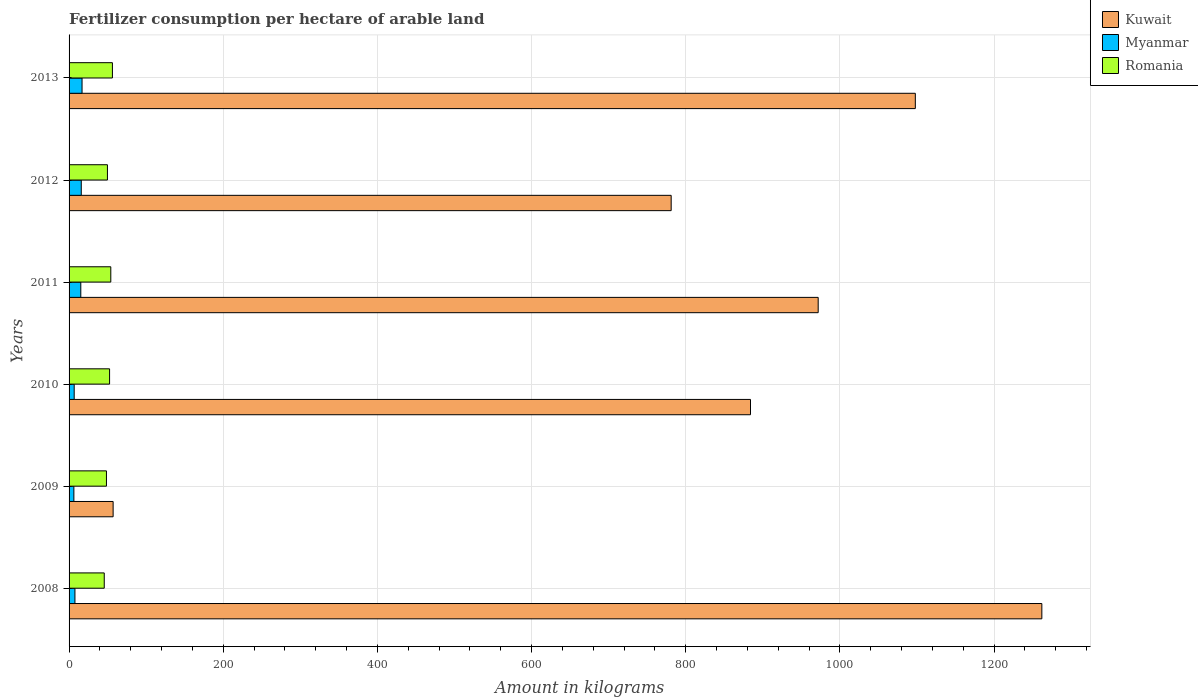How many different coloured bars are there?
Provide a succinct answer. 3. How many bars are there on the 1st tick from the top?
Provide a succinct answer. 3. What is the amount of fertilizer consumption in Kuwait in 2009?
Keep it short and to the point. 57.14. Across all years, what is the maximum amount of fertilizer consumption in Romania?
Make the answer very short. 56.23. Across all years, what is the minimum amount of fertilizer consumption in Romania?
Offer a very short reply. 45.64. In which year was the amount of fertilizer consumption in Myanmar maximum?
Offer a terse response. 2013. What is the total amount of fertilizer consumption in Romania in the graph?
Make the answer very short. 306.83. What is the difference between the amount of fertilizer consumption in Myanmar in 2009 and that in 2012?
Provide a short and direct response. -9.58. What is the difference between the amount of fertilizer consumption in Kuwait in 2011 and the amount of fertilizer consumption in Romania in 2013?
Your answer should be compact. 915.57. What is the average amount of fertilizer consumption in Myanmar per year?
Your response must be concise. 11.39. In the year 2008, what is the difference between the amount of fertilizer consumption in Romania and amount of fertilizer consumption in Kuwait?
Provide a short and direct response. -1216.31. In how many years, is the amount of fertilizer consumption in Romania greater than 360 kg?
Offer a very short reply. 0. What is the ratio of the amount of fertilizer consumption in Romania in 2008 to that in 2009?
Provide a succinct answer. 0.94. Is the amount of fertilizer consumption in Myanmar in 2008 less than that in 2011?
Provide a short and direct response. Yes. What is the difference between the highest and the second highest amount of fertilizer consumption in Myanmar?
Offer a very short reply. 1.02. What is the difference between the highest and the lowest amount of fertilizer consumption in Romania?
Provide a succinct answer. 10.6. In how many years, is the amount of fertilizer consumption in Myanmar greater than the average amount of fertilizer consumption in Myanmar taken over all years?
Provide a short and direct response. 3. What does the 1st bar from the top in 2008 represents?
Your response must be concise. Romania. What does the 2nd bar from the bottom in 2009 represents?
Give a very brief answer. Myanmar. How many bars are there?
Provide a succinct answer. 18. How many years are there in the graph?
Your answer should be compact. 6. What is the difference between two consecutive major ticks on the X-axis?
Ensure brevity in your answer.  200. How many legend labels are there?
Provide a short and direct response. 3. How are the legend labels stacked?
Your answer should be compact. Vertical. What is the title of the graph?
Give a very brief answer. Fertilizer consumption per hectare of arable land. Does "Mongolia" appear as one of the legend labels in the graph?
Offer a terse response. No. What is the label or title of the X-axis?
Offer a very short reply. Amount in kilograms. What is the Amount in kilograms of Kuwait in 2008?
Your answer should be compact. 1261.95. What is the Amount in kilograms of Myanmar in 2008?
Give a very brief answer. 7.61. What is the Amount in kilograms of Romania in 2008?
Make the answer very short. 45.64. What is the Amount in kilograms in Kuwait in 2009?
Ensure brevity in your answer.  57.14. What is the Amount in kilograms in Myanmar in 2009?
Keep it short and to the point. 6.24. What is the Amount in kilograms of Romania in 2009?
Your response must be concise. 48.49. What is the Amount in kilograms of Kuwait in 2010?
Your answer should be compact. 884. What is the Amount in kilograms of Myanmar in 2010?
Offer a terse response. 6.64. What is the Amount in kilograms of Romania in 2010?
Provide a short and direct response. 52.55. What is the Amount in kilograms in Kuwait in 2011?
Keep it short and to the point. 971.81. What is the Amount in kilograms of Myanmar in 2011?
Make the answer very short. 15.22. What is the Amount in kilograms in Romania in 2011?
Offer a very short reply. 54.13. What is the Amount in kilograms in Kuwait in 2012?
Make the answer very short. 781.1. What is the Amount in kilograms in Myanmar in 2012?
Your answer should be compact. 15.82. What is the Amount in kilograms of Romania in 2012?
Your response must be concise. 49.78. What is the Amount in kilograms in Kuwait in 2013?
Your answer should be compact. 1097.83. What is the Amount in kilograms in Myanmar in 2013?
Offer a very short reply. 16.83. What is the Amount in kilograms of Romania in 2013?
Provide a succinct answer. 56.23. Across all years, what is the maximum Amount in kilograms in Kuwait?
Provide a short and direct response. 1261.95. Across all years, what is the maximum Amount in kilograms in Myanmar?
Provide a succinct answer. 16.83. Across all years, what is the maximum Amount in kilograms in Romania?
Offer a terse response. 56.23. Across all years, what is the minimum Amount in kilograms in Kuwait?
Your answer should be compact. 57.14. Across all years, what is the minimum Amount in kilograms of Myanmar?
Your answer should be compact. 6.24. Across all years, what is the minimum Amount in kilograms of Romania?
Ensure brevity in your answer.  45.64. What is the total Amount in kilograms in Kuwait in the graph?
Provide a short and direct response. 5053.83. What is the total Amount in kilograms of Myanmar in the graph?
Offer a very short reply. 68.35. What is the total Amount in kilograms in Romania in the graph?
Provide a short and direct response. 306.83. What is the difference between the Amount in kilograms of Kuwait in 2008 and that in 2009?
Your answer should be compact. 1204.8. What is the difference between the Amount in kilograms in Myanmar in 2008 and that in 2009?
Give a very brief answer. 1.37. What is the difference between the Amount in kilograms of Romania in 2008 and that in 2009?
Your response must be concise. -2.86. What is the difference between the Amount in kilograms in Kuwait in 2008 and that in 2010?
Provide a short and direct response. 377.95. What is the difference between the Amount in kilograms in Myanmar in 2008 and that in 2010?
Offer a terse response. 0.97. What is the difference between the Amount in kilograms of Romania in 2008 and that in 2010?
Your answer should be very brief. -6.91. What is the difference between the Amount in kilograms of Kuwait in 2008 and that in 2011?
Provide a short and direct response. 290.14. What is the difference between the Amount in kilograms in Myanmar in 2008 and that in 2011?
Ensure brevity in your answer.  -7.61. What is the difference between the Amount in kilograms in Romania in 2008 and that in 2011?
Offer a terse response. -8.5. What is the difference between the Amount in kilograms of Kuwait in 2008 and that in 2012?
Provide a short and direct response. 480.85. What is the difference between the Amount in kilograms of Myanmar in 2008 and that in 2012?
Provide a short and direct response. -8.21. What is the difference between the Amount in kilograms of Romania in 2008 and that in 2012?
Offer a very short reply. -4.15. What is the difference between the Amount in kilograms in Kuwait in 2008 and that in 2013?
Offer a terse response. 164.12. What is the difference between the Amount in kilograms of Myanmar in 2008 and that in 2013?
Provide a succinct answer. -9.22. What is the difference between the Amount in kilograms in Romania in 2008 and that in 2013?
Provide a succinct answer. -10.6. What is the difference between the Amount in kilograms of Kuwait in 2009 and that in 2010?
Your response must be concise. -826.86. What is the difference between the Amount in kilograms of Myanmar in 2009 and that in 2010?
Give a very brief answer. -0.4. What is the difference between the Amount in kilograms of Romania in 2009 and that in 2010?
Give a very brief answer. -4.05. What is the difference between the Amount in kilograms of Kuwait in 2009 and that in 2011?
Keep it short and to the point. -914.67. What is the difference between the Amount in kilograms of Myanmar in 2009 and that in 2011?
Your answer should be very brief. -8.98. What is the difference between the Amount in kilograms in Romania in 2009 and that in 2011?
Make the answer very short. -5.64. What is the difference between the Amount in kilograms in Kuwait in 2009 and that in 2012?
Your answer should be compact. -723.96. What is the difference between the Amount in kilograms in Myanmar in 2009 and that in 2012?
Offer a very short reply. -9.58. What is the difference between the Amount in kilograms in Romania in 2009 and that in 2012?
Offer a terse response. -1.29. What is the difference between the Amount in kilograms of Kuwait in 2009 and that in 2013?
Keep it short and to the point. -1040.69. What is the difference between the Amount in kilograms of Myanmar in 2009 and that in 2013?
Offer a terse response. -10.6. What is the difference between the Amount in kilograms in Romania in 2009 and that in 2013?
Your answer should be compact. -7.74. What is the difference between the Amount in kilograms in Kuwait in 2010 and that in 2011?
Make the answer very short. -87.81. What is the difference between the Amount in kilograms of Myanmar in 2010 and that in 2011?
Ensure brevity in your answer.  -8.58. What is the difference between the Amount in kilograms in Romania in 2010 and that in 2011?
Ensure brevity in your answer.  -1.59. What is the difference between the Amount in kilograms of Kuwait in 2010 and that in 2012?
Your answer should be very brief. 102.9. What is the difference between the Amount in kilograms of Myanmar in 2010 and that in 2012?
Offer a very short reply. -9.18. What is the difference between the Amount in kilograms of Romania in 2010 and that in 2012?
Give a very brief answer. 2.77. What is the difference between the Amount in kilograms of Kuwait in 2010 and that in 2013?
Your response must be concise. -213.83. What is the difference between the Amount in kilograms in Myanmar in 2010 and that in 2013?
Ensure brevity in your answer.  -10.2. What is the difference between the Amount in kilograms in Romania in 2010 and that in 2013?
Your answer should be very brief. -3.69. What is the difference between the Amount in kilograms of Kuwait in 2011 and that in 2012?
Give a very brief answer. 190.71. What is the difference between the Amount in kilograms in Myanmar in 2011 and that in 2012?
Ensure brevity in your answer.  -0.6. What is the difference between the Amount in kilograms in Romania in 2011 and that in 2012?
Provide a short and direct response. 4.35. What is the difference between the Amount in kilograms of Kuwait in 2011 and that in 2013?
Keep it short and to the point. -126.02. What is the difference between the Amount in kilograms in Myanmar in 2011 and that in 2013?
Provide a short and direct response. -1.62. What is the difference between the Amount in kilograms of Romania in 2011 and that in 2013?
Your answer should be very brief. -2.1. What is the difference between the Amount in kilograms in Kuwait in 2012 and that in 2013?
Make the answer very short. -316.73. What is the difference between the Amount in kilograms of Myanmar in 2012 and that in 2013?
Your response must be concise. -1.02. What is the difference between the Amount in kilograms of Romania in 2012 and that in 2013?
Provide a succinct answer. -6.45. What is the difference between the Amount in kilograms of Kuwait in 2008 and the Amount in kilograms of Myanmar in 2009?
Provide a succinct answer. 1255.71. What is the difference between the Amount in kilograms of Kuwait in 2008 and the Amount in kilograms of Romania in 2009?
Provide a short and direct response. 1213.45. What is the difference between the Amount in kilograms in Myanmar in 2008 and the Amount in kilograms in Romania in 2009?
Provide a short and direct response. -40.88. What is the difference between the Amount in kilograms in Kuwait in 2008 and the Amount in kilograms in Myanmar in 2010?
Provide a short and direct response. 1255.31. What is the difference between the Amount in kilograms of Kuwait in 2008 and the Amount in kilograms of Romania in 2010?
Keep it short and to the point. 1209.4. What is the difference between the Amount in kilograms in Myanmar in 2008 and the Amount in kilograms in Romania in 2010?
Make the answer very short. -44.94. What is the difference between the Amount in kilograms of Kuwait in 2008 and the Amount in kilograms of Myanmar in 2011?
Offer a terse response. 1246.73. What is the difference between the Amount in kilograms in Kuwait in 2008 and the Amount in kilograms in Romania in 2011?
Ensure brevity in your answer.  1207.81. What is the difference between the Amount in kilograms in Myanmar in 2008 and the Amount in kilograms in Romania in 2011?
Provide a succinct answer. -46.53. What is the difference between the Amount in kilograms of Kuwait in 2008 and the Amount in kilograms of Myanmar in 2012?
Make the answer very short. 1246.13. What is the difference between the Amount in kilograms of Kuwait in 2008 and the Amount in kilograms of Romania in 2012?
Keep it short and to the point. 1212.17. What is the difference between the Amount in kilograms of Myanmar in 2008 and the Amount in kilograms of Romania in 2012?
Provide a short and direct response. -42.17. What is the difference between the Amount in kilograms in Kuwait in 2008 and the Amount in kilograms in Myanmar in 2013?
Provide a succinct answer. 1245.11. What is the difference between the Amount in kilograms in Kuwait in 2008 and the Amount in kilograms in Romania in 2013?
Provide a succinct answer. 1205.71. What is the difference between the Amount in kilograms in Myanmar in 2008 and the Amount in kilograms in Romania in 2013?
Make the answer very short. -48.63. What is the difference between the Amount in kilograms of Kuwait in 2009 and the Amount in kilograms of Myanmar in 2010?
Provide a succinct answer. 50.51. What is the difference between the Amount in kilograms of Kuwait in 2009 and the Amount in kilograms of Romania in 2010?
Ensure brevity in your answer.  4.6. What is the difference between the Amount in kilograms in Myanmar in 2009 and the Amount in kilograms in Romania in 2010?
Keep it short and to the point. -46.31. What is the difference between the Amount in kilograms of Kuwait in 2009 and the Amount in kilograms of Myanmar in 2011?
Your answer should be very brief. 41.93. What is the difference between the Amount in kilograms in Kuwait in 2009 and the Amount in kilograms in Romania in 2011?
Your response must be concise. 3.01. What is the difference between the Amount in kilograms in Myanmar in 2009 and the Amount in kilograms in Romania in 2011?
Provide a short and direct response. -47.9. What is the difference between the Amount in kilograms in Kuwait in 2009 and the Amount in kilograms in Myanmar in 2012?
Offer a very short reply. 41.32. What is the difference between the Amount in kilograms in Kuwait in 2009 and the Amount in kilograms in Romania in 2012?
Your answer should be compact. 7.36. What is the difference between the Amount in kilograms of Myanmar in 2009 and the Amount in kilograms of Romania in 2012?
Ensure brevity in your answer.  -43.54. What is the difference between the Amount in kilograms of Kuwait in 2009 and the Amount in kilograms of Myanmar in 2013?
Make the answer very short. 40.31. What is the difference between the Amount in kilograms of Kuwait in 2009 and the Amount in kilograms of Romania in 2013?
Provide a succinct answer. 0.91. What is the difference between the Amount in kilograms in Myanmar in 2009 and the Amount in kilograms in Romania in 2013?
Keep it short and to the point. -50. What is the difference between the Amount in kilograms of Kuwait in 2010 and the Amount in kilograms of Myanmar in 2011?
Your answer should be compact. 868.78. What is the difference between the Amount in kilograms in Kuwait in 2010 and the Amount in kilograms in Romania in 2011?
Provide a succinct answer. 829.87. What is the difference between the Amount in kilograms of Myanmar in 2010 and the Amount in kilograms of Romania in 2011?
Your answer should be compact. -47.5. What is the difference between the Amount in kilograms of Kuwait in 2010 and the Amount in kilograms of Myanmar in 2012?
Provide a succinct answer. 868.18. What is the difference between the Amount in kilograms of Kuwait in 2010 and the Amount in kilograms of Romania in 2012?
Provide a succinct answer. 834.22. What is the difference between the Amount in kilograms of Myanmar in 2010 and the Amount in kilograms of Romania in 2012?
Make the answer very short. -43.14. What is the difference between the Amount in kilograms in Kuwait in 2010 and the Amount in kilograms in Myanmar in 2013?
Offer a very short reply. 867.17. What is the difference between the Amount in kilograms of Kuwait in 2010 and the Amount in kilograms of Romania in 2013?
Ensure brevity in your answer.  827.76. What is the difference between the Amount in kilograms of Myanmar in 2010 and the Amount in kilograms of Romania in 2013?
Make the answer very short. -49.6. What is the difference between the Amount in kilograms in Kuwait in 2011 and the Amount in kilograms in Myanmar in 2012?
Ensure brevity in your answer.  955.99. What is the difference between the Amount in kilograms of Kuwait in 2011 and the Amount in kilograms of Romania in 2012?
Keep it short and to the point. 922.03. What is the difference between the Amount in kilograms in Myanmar in 2011 and the Amount in kilograms in Romania in 2012?
Offer a very short reply. -34.56. What is the difference between the Amount in kilograms of Kuwait in 2011 and the Amount in kilograms of Myanmar in 2013?
Provide a short and direct response. 954.98. What is the difference between the Amount in kilograms of Kuwait in 2011 and the Amount in kilograms of Romania in 2013?
Keep it short and to the point. 915.57. What is the difference between the Amount in kilograms in Myanmar in 2011 and the Amount in kilograms in Romania in 2013?
Ensure brevity in your answer.  -41.02. What is the difference between the Amount in kilograms in Kuwait in 2012 and the Amount in kilograms in Myanmar in 2013?
Your answer should be compact. 764.27. What is the difference between the Amount in kilograms in Kuwait in 2012 and the Amount in kilograms in Romania in 2013?
Offer a very short reply. 724.87. What is the difference between the Amount in kilograms in Myanmar in 2012 and the Amount in kilograms in Romania in 2013?
Your response must be concise. -40.42. What is the average Amount in kilograms in Kuwait per year?
Provide a succinct answer. 842.3. What is the average Amount in kilograms of Myanmar per year?
Your answer should be compact. 11.39. What is the average Amount in kilograms of Romania per year?
Your response must be concise. 51.14. In the year 2008, what is the difference between the Amount in kilograms of Kuwait and Amount in kilograms of Myanmar?
Offer a very short reply. 1254.34. In the year 2008, what is the difference between the Amount in kilograms of Kuwait and Amount in kilograms of Romania?
Give a very brief answer. 1216.31. In the year 2008, what is the difference between the Amount in kilograms of Myanmar and Amount in kilograms of Romania?
Offer a terse response. -38.03. In the year 2009, what is the difference between the Amount in kilograms in Kuwait and Amount in kilograms in Myanmar?
Your answer should be compact. 50.91. In the year 2009, what is the difference between the Amount in kilograms of Kuwait and Amount in kilograms of Romania?
Keep it short and to the point. 8.65. In the year 2009, what is the difference between the Amount in kilograms of Myanmar and Amount in kilograms of Romania?
Give a very brief answer. -42.26. In the year 2010, what is the difference between the Amount in kilograms in Kuwait and Amount in kilograms in Myanmar?
Provide a succinct answer. 877.36. In the year 2010, what is the difference between the Amount in kilograms in Kuwait and Amount in kilograms in Romania?
Ensure brevity in your answer.  831.45. In the year 2010, what is the difference between the Amount in kilograms of Myanmar and Amount in kilograms of Romania?
Provide a succinct answer. -45.91. In the year 2011, what is the difference between the Amount in kilograms of Kuwait and Amount in kilograms of Myanmar?
Make the answer very short. 956.59. In the year 2011, what is the difference between the Amount in kilograms in Kuwait and Amount in kilograms in Romania?
Ensure brevity in your answer.  917.67. In the year 2011, what is the difference between the Amount in kilograms of Myanmar and Amount in kilograms of Romania?
Provide a succinct answer. -38.92. In the year 2012, what is the difference between the Amount in kilograms of Kuwait and Amount in kilograms of Myanmar?
Your answer should be compact. 765.28. In the year 2012, what is the difference between the Amount in kilograms of Kuwait and Amount in kilograms of Romania?
Offer a terse response. 731.32. In the year 2012, what is the difference between the Amount in kilograms of Myanmar and Amount in kilograms of Romania?
Provide a succinct answer. -33.96. In the year 2013, what is the difference between the Amount in kilograms of Kuwait and Amount in kilograms of Myanmar?
Ensure brevity in your answer.  1081. In the year 2013, what is the difference between the Amount in kilograms in Kuwait and Amount in kilograms in Romania?
Provide a succinct answer. 1041.6. In the year 2013, what is the difference between the Amount in kilograms of Myanmar and Amount in kilograms of Romania?
Your answer should be compact. -39.4. What is the ratio of the Amount in kilograms in Kuwait in 2008 to that in 2009?
Provide a succinct answer. 22.08. What is the ratio of the Amount in kilograms in Myanmar in 2008 to that in 2009?
Your response must be concise. 1.22. What is the ratio of the Amount in kilograms of Romania in 2008 to that in 2009?
Offer a very short reply. 0.94. What is the ratio of the Amount in kilograms in Kuwait in 2008 to that in 2010?
Make the answer very short. 1.43. What is the ratio of the Amount in kilograms in Myanmar in 2008 to that in 2010?
Your answer should be compact. 1.15. What is the ratio of the Amount in kilograms of Romania in 2008 to that in 2010?
Offer a terse response. 0.87. What is the ratio of the Amount in kilograms of Kuwait in 2008 to that in 2011?
Keep it short and to the point. 1.3. What is the ratio of the Amount in kilograms in Myanmar in 2008 to that in 2011?
Give a very brief answer. 0.5. What is the ratio of the Amount in kilograms of Romania in 2008 to that in 2011?
Make the answer very short. 0.84. What is the ratio of the Amount in kilograms of Kuwait in 2008 to that in 2012?
Keep it short and to the point. 1.62. What is the ratio of the Amount in kilograms in Myanmar in 2008 to that in 2012?
Offer a very short reply. 0.48. What is the ratio of the Amount in kilograms of Kuwait in 2008 to that in 2013?
Give a very brief answer. 1.15. What is the ratio of the Amount in kilograms in Myanmar in 2008 to that in 2013?
Provide a succinct answer. 0.45. What is the ratio of the Amount in kilograms of Romania in 2008 to that in 2013?
Offer a very short reply. 0.81. What is the ratio of the Amount in kilograms in Kuwait in 2009 to that in 2010?
Your answer should be very brief. 0.06. What is the ratio of the Amount in kilograms of Myanmar in 2009 to that in 2010?
Offer a terse response. 0.94. What is the ratio of the Amount in kilograms in Romania in 2009 to that in 2010?
Provide a succinct answer. 0.92. What is the ratio of the Amount in kilograms in Kuwait in 2009 to that in 2011?
Offer a very short reply. 0.06. What is the ratio of the Amount in kilograms of Myanmar in 2009 to that in 2011?
Your answer should be very brief. 0.41. What is the ratio of the Amount in kilograms in Romania in 2009 to that in 2011?
Give a very brief answer. 0.9. What is the ratio of the Amount in kilograms of Kuwait in 2009 to that in 2012?
Give a very brief answer. 0.07. What is the ratio of the Amount in kilograms of Myanmar in 2009 to that in 2012?
Your answer should be compact. 0.39. What is the ratio of the Amount in kilograms in Romania in 2009 to that in 2012?
Your answer should be compact. 0.97. What is the ratio of the Amount in kilograms of Kuwait in 2009 to that in 2013?
Provide a short and direct response. 0.05. What is the ratio of the Amount in kilograms in Myanmar in 2009 to that in 2013?
Your answer should be very brief. 0.37. What is the ratio of the Amount in kilograms of Romania in 2009 to that in 2013?
Offer a terse response. 0.86. What is the ratio of the Amount in kilograms of Kuwait in 2010 to that in 2011?
Your response must be concise. 0.91. What is the ratio of the Amount in kilograms in Myanmar in 2010 to that in 2011?
Provide a short and direct response. 0.44. What is the ratio of the Amount in kilograms of Romania in 2010 to that in 2011?
Give a very brief answer. 0.97. What is the ratio of the Amount in kilograms of Kuwait in 2010 to that in 2012?
Give a very brief answer. 1.13. What is the ratio of the Amount in kilograms in Myanmar in 2010 to that in 2012?
Offer a very short reply. 0.42. What is the ratio of the Amount in kilograms of Romania in 2010 to that in 2012?
Make the answer very short. 1.06. What is the ratio of the Amount in kilograms in Kuwait in 2010 to that in 2013?
Keep it short and to the point. 0.81. What is the ratio of the Amount in kilograms in Myanmar in 2010 to that in 2013?
Provide a succinct answer. 0.39. What is the ratio of the Amount in kilograms of Romania in 2010 to that in 2013?
Your answer should be compact. 0.93. What is the ratio of the Amount in kilograms of Kuwait in 2011 to that in 2012?
Ensure brevity in your answer.  1.24. What is the ratio of the Amount in kilograms in Myanmar in 2011 to that in 2012?
Offer a terse response. 0.96. What is the ratio of the Amount in kilograms of Romania in 2011 to that in 2012?
Ensure brevity in your answer.  1.09. What is the ratio of the Amount in kilograms in Kuwait in 2011 to that in 2013?
Your answer should be compact. 0.89. What is the ratio of the Amount in kilograms in Myanmar in 2011 to that in 2013?
Provide a short and direct response. 0.9. What is the ratio of the Amount in kilograms in Romania in 2011 to that in 2013?
Offer a very short reply. 0.96. What is the ratio of the Amount in kilograms in Kuwait in 2012 to that in 2013?
Offer a very short reply. 0.71. What is the ratio of the Amount in kilograms in Myanmar in 2012 to that in 2013?
Keep it short and to the point. 0.94. What is the ratio of the Amount in kilograms in Romania in 2012 to that in 2013?
Offer a terse response. 0.89. What is the difference between the highest and the second highest Amount in kilograms in Kuwait?
Keep it short and to the point. 164.12. What is the difference between the highest and the second highest Amount in kilograms in Myanmar?
Your answer should be very brief. 1.02. What is the difference between the highest and the lowest Amount in kilograms in Kuwait?
Offer a terse response. 1204.8. What is the difference between the highest and the lowest Amount in kilograms of Myanmar?
Give a very brief answer. 10.6. What is the difference between the highest and the lowest Amount in kilograms of Romania?
Ensure brevity in your answer.  10.6. 